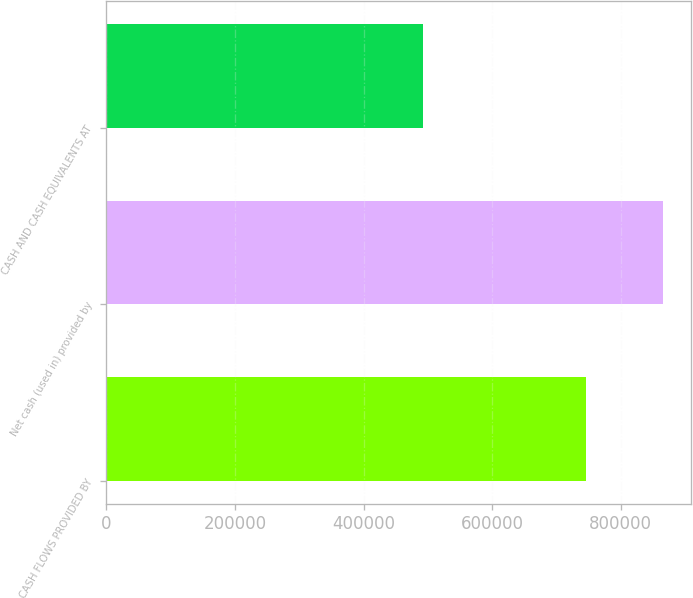Convert chart. <chart><loc_0><loc_0><loc_500><loc_500><bar_chart><fcel>CASH FLOWS PROVIDED BY<fcel>Net cash (used in) provided by<fcel>CASH AND CASH EQUIVALENTS AT<nl><fcel>745108<fcel>866281<fcel>491912<nl></chart> 